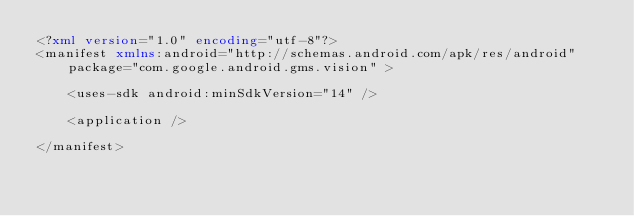<code> <loc_0><loc_0><loc_500><loc_500><_XML_><?xml version="1.0" encoding="utf-8"?>
<manifest xmlns:android="http://schemas.android.com/apk/res/android"
    package="com.google.android.gms.vision" >

    <uses-sdk android:minSdkVersion="14" />

    <application />

</manifest></code> 